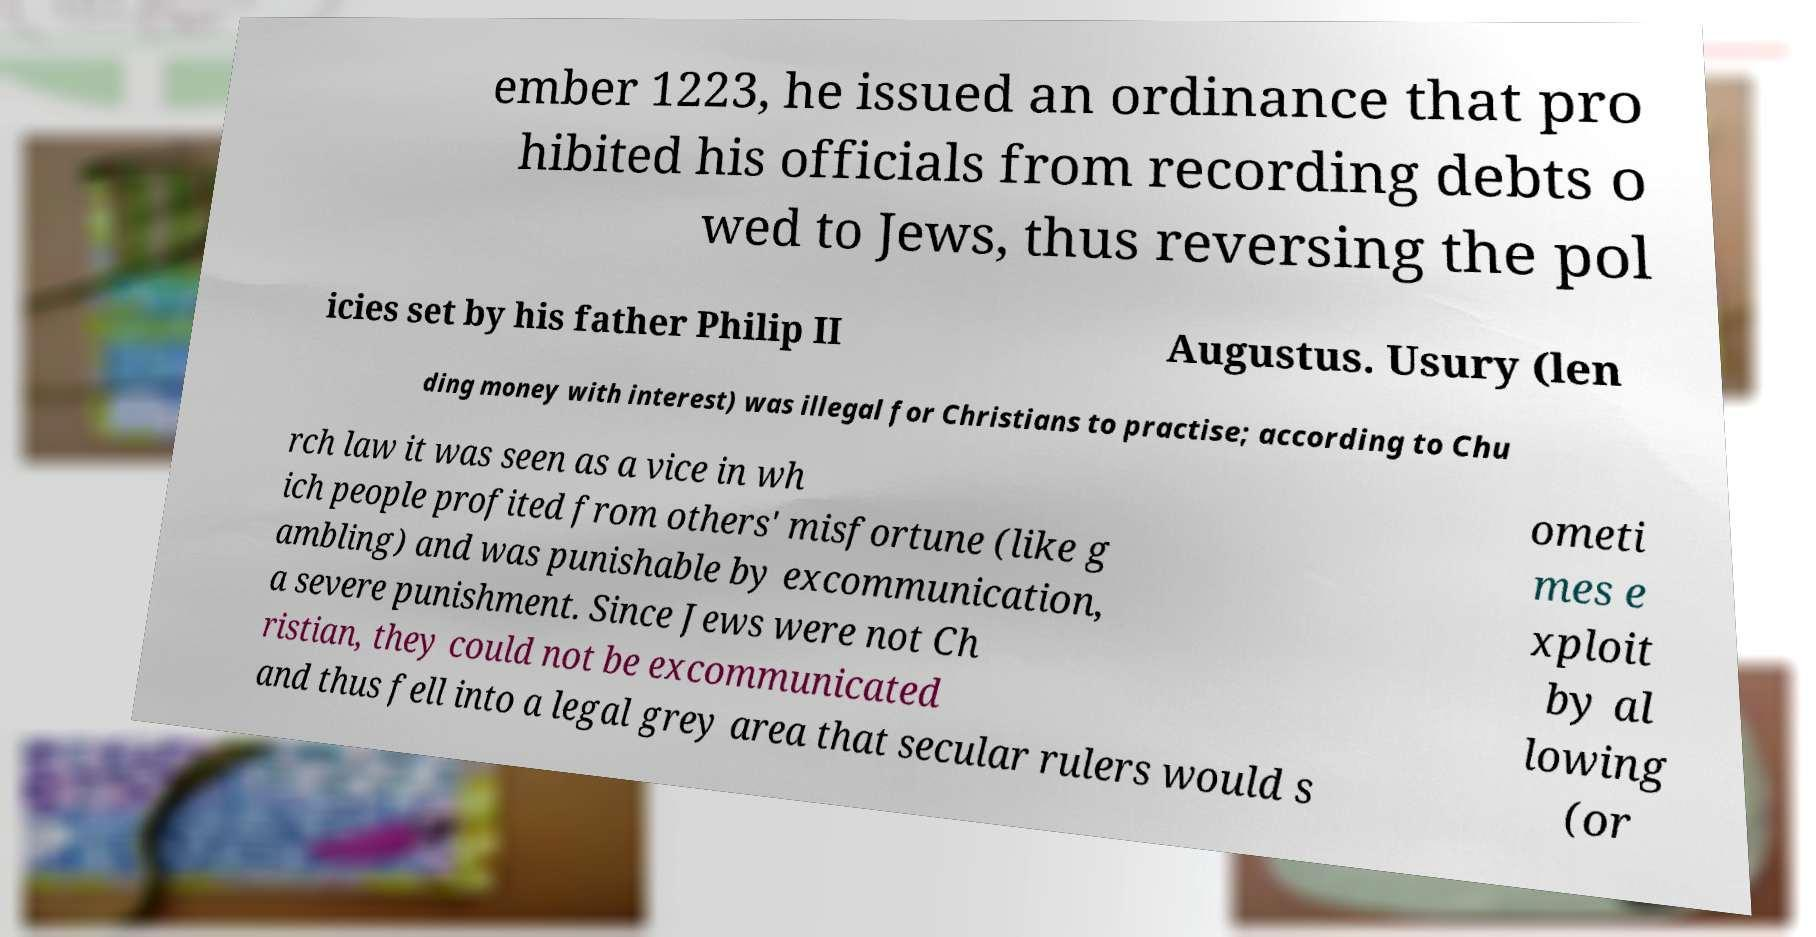For documentation purposes, I need the text within this image transcribed. Could you provide that? ember 1223, he issued an ordinance that pro hibited his officials from recording debts o wed to Jews, thus reversing the pol icies set by his father Philip II Augustus. Usury (len ding money with interest) was illegal for Christians to practise; according to Chu rch law it was seen as a vice in wh ich people profited from others' misfortune (like g ambling) and was punishable by excommunication, a severe punishment. Since Jews were not Ch ristian, they could not be excommunicated and thus fell into a legal grey area that secular rulers would s ometi mes e xploit by al lowing (or 